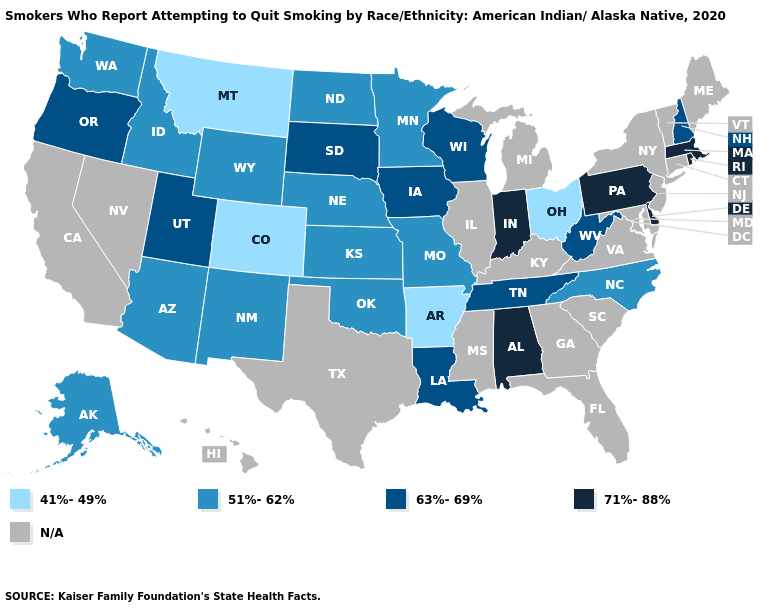Does the map have missing data?
Be succinct. Yes. What is the lowest value in the USA?
Keep it brief. 41%-49%. Name the states that have a value in the range 63%-69%?
Write a very short answer. Iowa, Louisiana, New Hampshire, Oregon, South Dakota, Tennessee, Utah, West Virginia, Wisconsin. Does Arkansas have the lowest value in the USA?
Answer briefly. Yes. Name the states that have a value in the range 63%-69%?
Answer briefly. Iowa, Louisiana, New Hampshire, Oregon, South Dakota, Tennessee, Utah, West Virginia, Wisconsin. What is the value of Wyoming?
Short answer required. 51%-62%. Name the states that have a value in the range 71%-88%?
Short answer required. Alabama, Delaware, Indiana, Massachusetts, Pennsylvania, Rhode Island. Name the states that have a value in the range 41%-49%?
Write a very short answer. Arkansas, Colorado, Montana, Ohio. Does New Hampshire have the lowest value in the Northeast?
Give a very brief answer. Yes. What is the value of North Carolina?
Give a very brief answer. 51%-62%. Name the states that have a value in the range 71%-88%?
Be succinct. Alabama, Delaware, Indiana, Massachusetts, Pennsylvania, Rhode Island. 